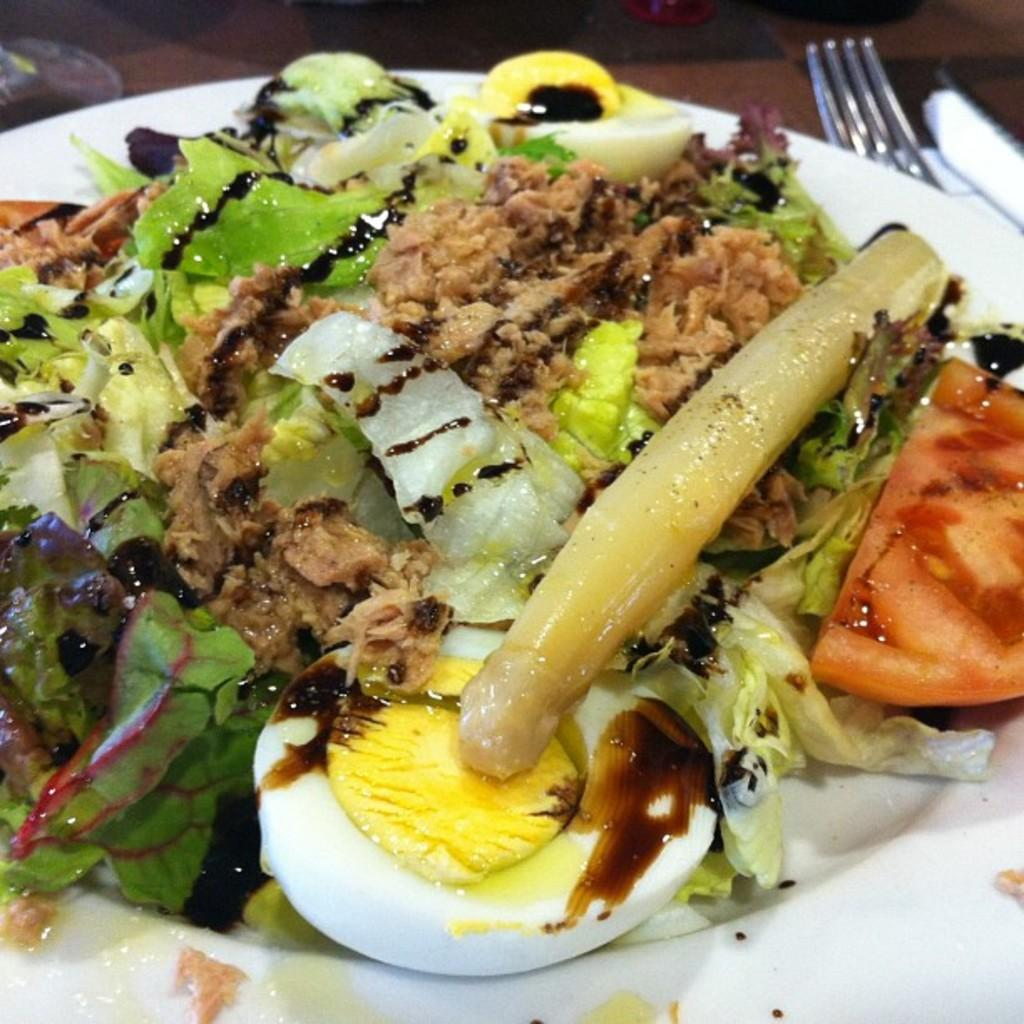What is on the white plate in the image? There is food on a white plate in the image. What utensils are present in the image? There is a fork and a knife in the image. What else can be seen on the table in the image? There are objects on the table in the image. How many frogs are sitting on the cheese in the image? There are no frogs or cheese present in the image. What type of stew is being served in the image? There is no stew present in the image; it only shows food on a white plate. 